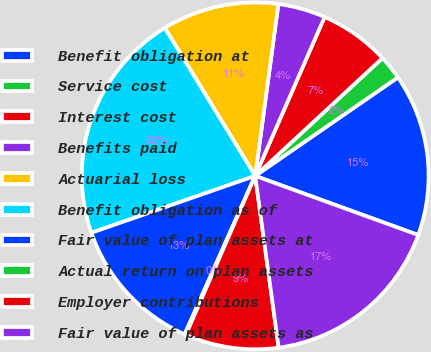<chart> <loc_0><loc_0><loc_500><loc_500><pie_chart><fcel>Benefit obligation at<fcel>Service cost<fcel>Interest cost<fcel>Benefits paid<fcel>Actuarial loss<fcel>Benefit obligation as of<fcel>Fair value of plan assets at<fcel>Actual return on plan assets<fcel>Employer contributions<fcel>Fair value of plan assets as<nl><fcel>15.15%<fcel>2.27%<fcel>6.56%<fcel>4.42%<fcel>10.86%<fcel>21.59%<fcel>13.01%<fcel>0.12%<fcel>8.71%<fcel>17.3%<nl></chart> 